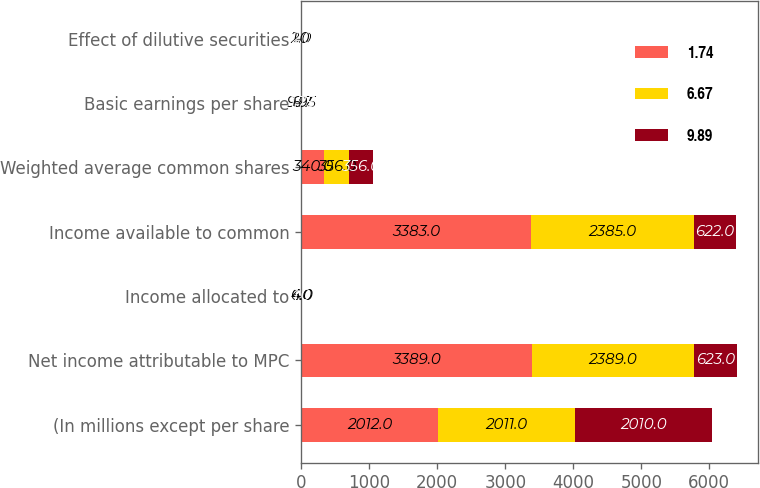<chart> <loc_0><loc_0><loc_500><loc_500><stacked_bar_chart><ecel><fcel>(In millions except per share<fcel>Net income attributable to MPC<fcel>Income allocated to<fcel>Income available to common<fcel>Weighted average common shares<fcel>Basic earnings per share<fcel>Effect of dilutive securities<nl><fcel>1.74<fcel>2012<fcel>3389<fcel>6<fcel>3383<fcel>340<fcel>9.95<fcel>2<nl><fcel>6.67<fcel>2011<fcel>2389<fcel>4<fcel>2385<fcel>356<fcel>6.7<fcel>1<nl><fcel>9.89<fcel>2010<fcel>623<fcel>1<fcel>622<fcel>356<fcel>1.75<fcel>2<nl></chart> 